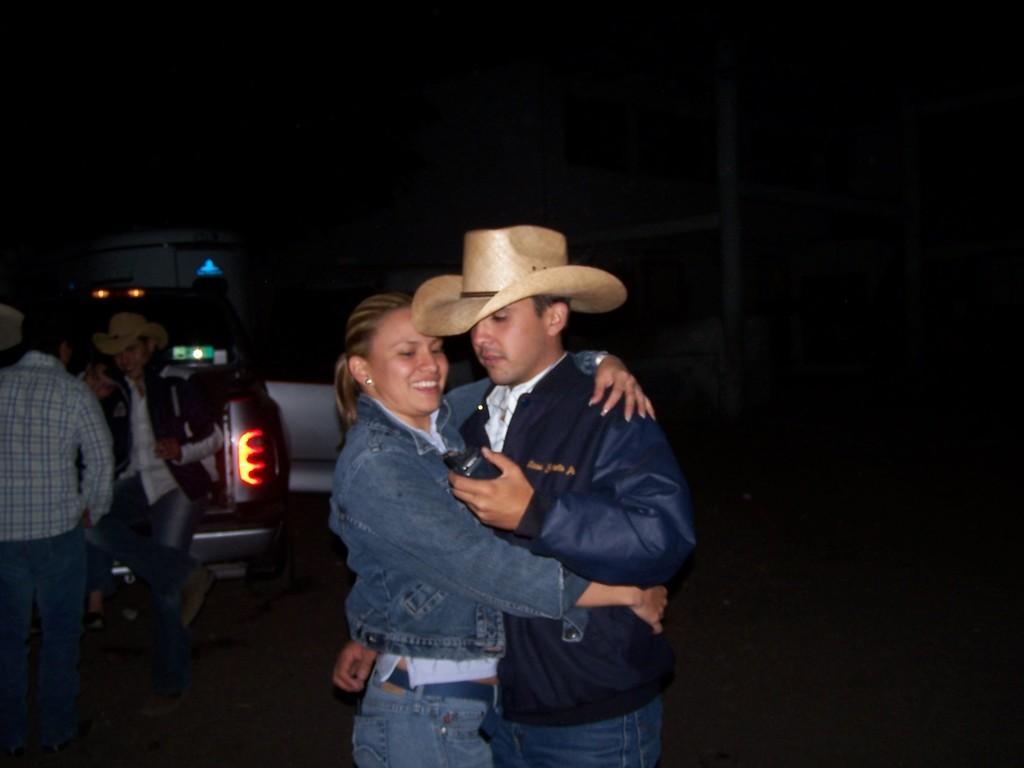Describe this image in one or two sentences. In this picture I can observe a couple in the middle of the picture. On the right side I can observe few people and a vehicle. The background is completely dark. 